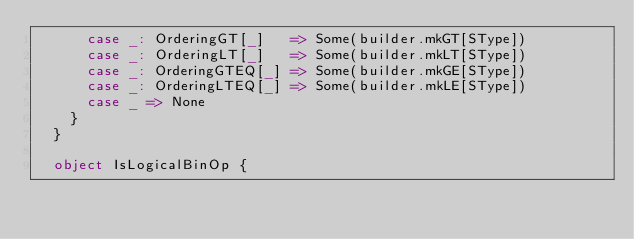Convert code to text. <code><loc_0><loc_0><loc_500><loc_500><_Scala_>      case _: OrderingGT[_]   => Some(builder.mkGT[SType])
      case _: OrderingLT[_]   => Some(builder.mkLT[SType])
      case _: OrderingGTEQ[_] => Some(builder.mkGE[SType])
      case _: OrderingLTEQ[_] => Some(builder.mkLE[SType])
      case _ => None
    }
  }

  object IsLogicalBinOp {</code> 